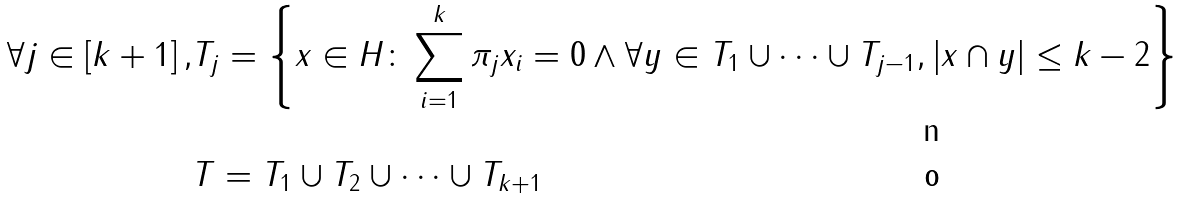Convert formula to latex. <formula><loc_0><loc_0><loc_500><loc_500>\forall j \in \left [ k + 1 \right ] , & T _ { j } = \left \{ x \in H \colon \sum _ { i = 1 } ^ { k } \pi _ { j } x _ { i } = 0 \land \forall y \in T _ { 1 } \cup \dots \cup T _ { j - 1 } , \left | x \cap y \right | \leq k - 2 \right \} \\ & T = T _ { 1 } \cup T _ { 2 } \cup \dots \cup T _ { k + 1 }</formula> 